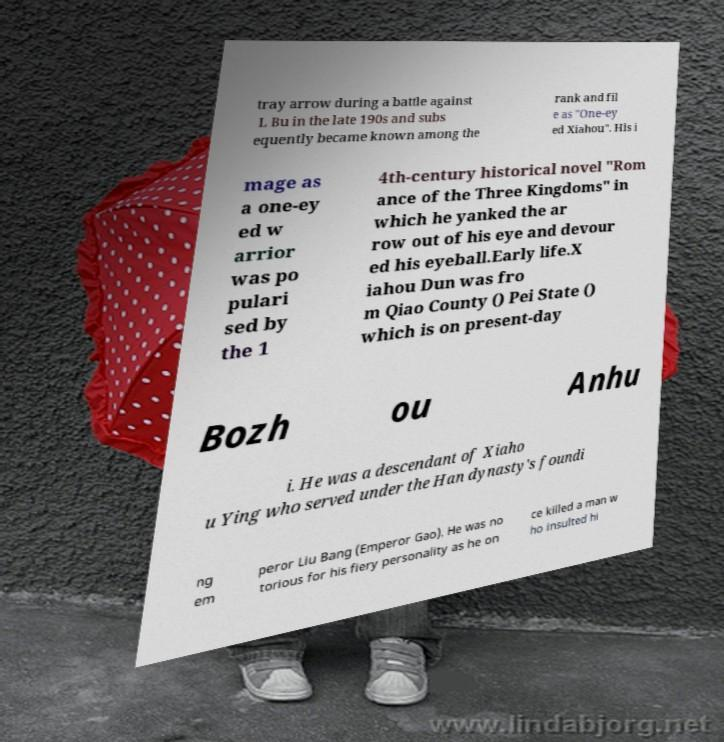Can you accurately transcribe the text from the provided image for me? tray arrow during a battle against L Bu in the late 190s and subs equently became known among the rank and fil e as "One-ey ed Xiahou". His i mage as a one-ey ed w arrior was po pulari sed by the 1 4th-century historical novel "Rom ance of the Three Kingdoms" in which he yanked the ar row out of his eye and devour ed his eyeball.Early life.X iahou Dun was fro m Qiao County () Pei State () which is on present-day Bozh ou Anhu i. He was a descendant of Xiaho u Ying who served under the Han dynasty's foundi ng em peror Liu Bang (Emperor Gao). He was no torious for his fiery personality as he on ce killed a man w ho insulted hi 